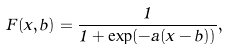Convert formula to latex. <formula><loc_0><loc_0><loc_500><loc_500>F ( x , b ) = \frac { 1 } { 1 + \exp ( - a ( x - b ) ) } ,</formula> 